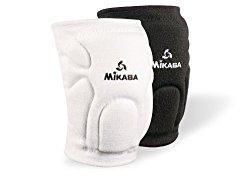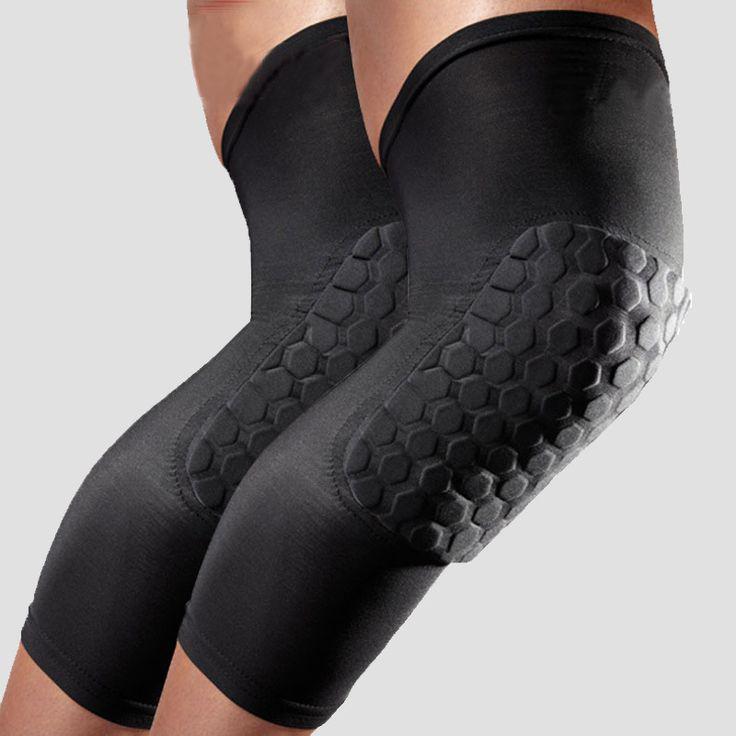The first image is the image on the left, the second image is the image on the right. Given the left and right images, does the statement "The combined images include two black knee pads worn on bent human knees that face right." hold true? Answer yes or no. Yes. The first image is the image on the left, the second image is the image on the right. Examine the images to the left and right. Is the description "At least one of the knee braces is white." accurate? Answer yes or no. Yes. 